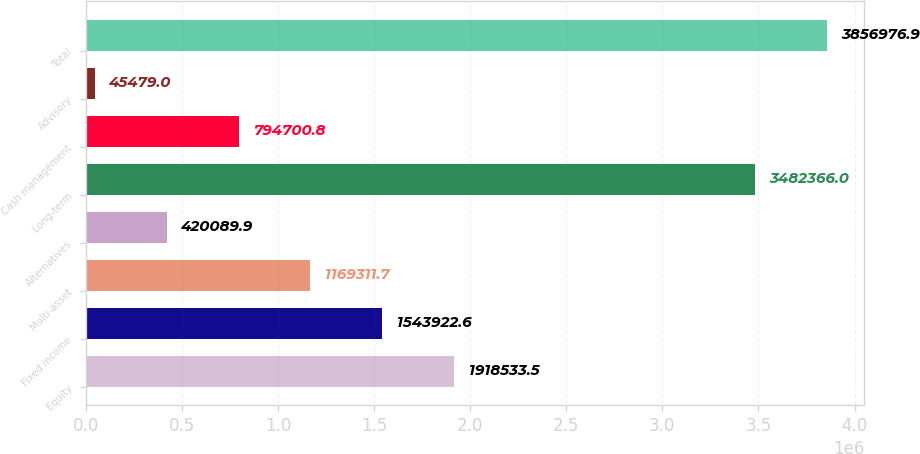Convert chart to OTSL. <chart><loc_0><loc_0><loc_500><loc_500><bar_chart><fcel>Equity<fcel>Fixed income<fcel>Multi-asset<fcel>Alternatives<fcel>Long-term<fcel>Cash management<fcel>Advisory<fcel>Total<nl><fcel>1.91853e+06<fcel>1.54392e+06<fcel>1.16931e+06<fcel>420090<fcel>3.48237e+06<fcel>794701<fcel>45479<fcel>3.85698e+06<nl></chart> 